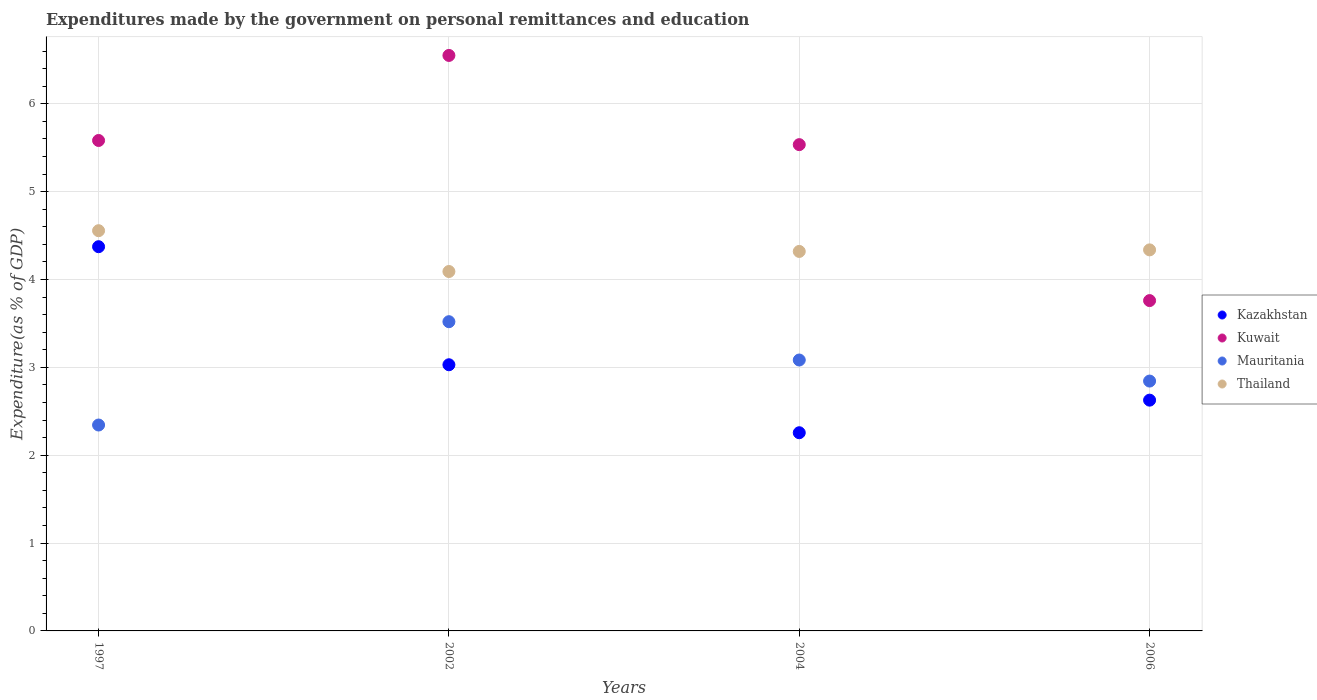Is the number of dotlines equal to the number of legend labels?
Give a very brief answer. Yes. What is the expenditures made by the government on personal remittances and education in Mauritania in 2002?
Offer a terse response. 3.52. Across all years, what is the maximum expenditures made by the government on personal remittances and education in Kuwait?
Your response must be concise. 6.55. Across all years, what is the minimum expenditures made by the government on personal remittances and education in Kazakhstan?
Ensure brevity in your answer.  2.26. In which year was the expenditures made by the government on personal remittances and education in Mauritania minimum?
Your answer should be compact. 1997. What is the total expenditures made by the government on personal remittances and education in Thailand in the graph?
Offer a very short reply. 17.3. What is the difference between the expenditures made by the government on personal remittances and education in Kuwait in 1997 and that in 2002?
Your answer should be compact. -0.97. What is the difference between the expenditures made by the government on personal remittances and education in Kazakhstan in 2006 and the expenditures made by the government on personal remittances and education in Kuwait in 1997?
Your answer should be very brief. -2.96. What is the average expenditures made by the government on personal remittances and education in Thailand per year?
Provide a short and direct response. 4.33. In the year 2002, what is the difference between the expenditures made by the government on personal remittances and education in Kuwait and expenditures made by the government on personal remittances and education in Kazakhstan?
Offer a terse response. 3.52. What is the ratio of the expenditures made by the government on personal remittances and education in Kuwait in 2002 to that in 2006?
Offer a very short reply. 1.74. Is the expenditures made by the government on personal remittances and education in Thailand in 1997 less than that in 2004?
Offer a terse response. No. What is the difference between the highest and the second highest expenditures made by the government on personal remittances and education in Kuwait?
Ensure brevity in your answer.  0.97. What is the difference between the highest and the lowest expenditures made by the government on personal remittances and education in Mauritania?
Your answer should be compact. 1.18. Is the sum of the expenditures made by the government on personal remittances and education in Thailand in 1997 and 2004 greater than the maximum expenditures made by the government on personal remittances and education in Kazakhstan across all years?
Ensure brevity in your answer.  Yes. Is it the case that in every year, the sum of the expenditures made by the government on personal remittances and education in Thailand and expenditures made by the government on personal remittances and education in Kuwait  is greater than the expenditures made by the government on personal remittances and education in Kazakhstan?
Provide a succinct answer. Yes. Does the expenditures made by the government on personal remittances and education in Kazakhstan monotonically increase over the years?
Make the answer very short. No. Is the expenditures made by the government on personal remittances and education in Kazakhstan strictly greater than the expenditures made by the government on personal remittances and education in Mauritania over the years?
Your response must be concise. No. How many dotlines are there?
Provide a succinct answer. 4. How many years are there in the graph?
Give a very brief answer. 4. What is the difference between two consecutive major ticks on the Y-axis?
Provide a succinct answer. 1. Does the graph contain any zero values?
Ensure brevity in your answer.  No. Does the graph contain grids?
Your response must be concise. Yes. How many legend labels are there?
Give a very brief answer. 4. How are the legend labels stacked?
Offer a very short reply. Vertical. What is the title of the graph?
Your answer should be very brief. Expenditures made by the government on personal remittances and education. Does "Ghana" appear as one of the legend labels in the graph?
Your response must be concise. No. What is the label or title of the Y-axis?
Offer a terse response. Expenditure(as % of GDP). What is the Expenditure(as % of GDP) in Kazakhstan in 1997?
Give a very brief answer. 4.37. What is the Expenditure(as % of GDP) in Kuwait in 1997?
Provide a short and direct response. 5.58. What is the Expenditure(as % of GDP) of Mauritania in 1997?
Ensure brevity in your answer.  2.34. What is the Expenditure(as % of GDP) in Thailand in 1997?
Offer a terse response. 4.56. What is the Expenditure(as % of GDP) of Kazakhstan in 2002?
Provide a short and direct response. 3.03. What is the Expenditure(as % of GDP) in Kuwait in 2002?
Provide a succinct answer. 6.55. What is the Expenditure(as % of GDP) of Mauritania in 2002?
Your response must be concise. 3.52. What is the Expenditure(as % of GDP) in Thailand in 2002?
Provide a succinct answer. 4.09. What is the Expenditure(as % of GDP) of Kazakhstan in 2004?
Make the answer very short. 2.26. What is the Expenditure(as % of GDP) in Kuwait in 2004?
Offer a terse response. 5.54. What is the Expenditure(as % of GDP) in Mauritania in 2004?
Your response must be concise. 3.08. What is the Expenditure(as % of GDP) of Thailand in 2004?
Your response must be concise. 4.32. What is the Expenditure(as % of GDP) of Kazakhstan in 2006?
Your answer should be compact. 2.63. What is the Expenditure(as % of GDP) in Kuwait in 2006?
Give a very brief answer. 3.76. What is the Expenditure(as % of GDP) in Mauritania in 2006?
Offer a terse response. 2.84. What is the Expenditure(as % of GDP) in Thailand in 2006?
Provide a succinct answer. 4.34. Across all years, what is the maximum Expenditure(as % of GDP) of Kazakhstan?
Your answer should be compact. 4.37. Across all years, what is the maximum Expenditure(as % of GDP) in Kuwait?
Keep it short and to the point. 6.55. Across all years, what is the maximum Expenditure(as % of GDP) in Mauritania?
Give a very brief answer. 3.52. Across all years, what is the maximum Expenditure(as % of GDP) of Thailand?
Keep it short and to the point. 4.56. Across all years, what is the minimum Expenditure(as % of GDP) of Kazakhstan?
Ensure brevity in your answer.  2.26. Across all years, what is the minimum Expenditure(as % of GDP) of Kuwait?
Make the answer very short. 3.76. Across all years, what is the minimum Expenditure(as % of GDP) in Mauritania?
Your response must be concise. 2.34. Across all years, what is the minimum Expenditure(as % of GDP) of Thailand?
Offer a very short reply. 4.09. What is the total Expenditure(as % of GDP) of Kazakhstan in the graph?
Your answer should be very brief. 12.29. What is the total Expenditure(as % of GDP) in Kuwait in the graph?
Ensure brevity in your answer.  21.43. What is the total Expenditure(as % of GDP) in Mauritania in the graph?
Provide a short and direct response. 11.79. What is the total Expenditure(as % of GDP) in Thailand in the graph?
Your answer should be compact. 17.3. What is the difference between the Expenditure(as % of GDP) in Kazakhstan in 1997 and that in 2002?
Offer a very short reply. 1.34. What is the difference between the Expenditure(as % of GDP) in Kuwait in 1997 and that in 2002?
Make the answer very short. -0.97. What is the difference between the Expenditure(as % of GDP) in Mauritania in 1997 and that in 2002?
Offer a very short reply. -1.18. What is the difference between the Expenditure(as % of GDP) in Thailand in 1997 and that in 2002?
Your response must be concise. 0.46. What is the difference between the Expenditure(as % of GDP) in Kazakhstan in 1997 and that in 2004?
Provide a short and direct response. 2.12. What is the difference between the Expenditure(as % of GDP) of Kuwait in 1997 and that in 2004?
Offer a terse response. 0.05. What is the difference between the Expenditure(as % of GDP) of Mauritania in 1997 and that in 2004?
Give a very brief answer. -0.74. What is the difference between the Expenditure(as % of GDP) of Thailand in 1997 and that in 2004?
Give a very brief answer. 0.24. What is the difference between the Expenditure(as % of GDP) of Kazakhstan in 1997 and that in 2006?
Offer a very short reply. 1.75. What is the difference between the Expenditure(as % of GDP) of Kuwait in 1997 and that in 2006?
Offer a terse response. 1.82. What is the difference between the Expenditure(as % of GDP) of Mauritania in 1997 and that in 2006?
Your answer should be compact. -0.5. What is the difference between the Expenditure(as % of GDP) in Thailand in 1997 and that in 2006?
Offer a terse response. 0.22. What is the difference between the Expenditure(as % of GDP) of Kazakhstan in 2002 and that in 2004?
Provide a succinct answer. 0.77. What is the difference between the Expenditure(as % of GDP) of Kuwait in 2002 and that in 2004?
Make the answer very short. 1.02. What is the difference between the Expenditure(as % of GDP) of Mauritania in 2002 and that in 2004?
Offer a very short reply. 0.44. What is the difference between the Expenditure(as % of GDP) in Thailand in 2002 and that in 2004?
Give a very brief answer. -0.23. What is the difference between the Expenditure(as % of GDP) in Kazakhstan in 2002 and that in 2006?
Provide a short and direct response. 0.4. What is the difference between the Expenditure(as % of GDP) in Kuwait in 2002 and that in 2006?
Your answer should be very brief. 2.79. What is the difference between the Expenditure(as % of GDP) of Mauritania in 2002 and that in 2006?
Keep it short and to the point. 0.68. What is the difference between the Expenditure(as % of GDP) of Thailand in 2002 and that in 2006?
Your answer should be very brief. -0.25. What is the difference between the Expenditure(as % of GDP) in Kazakhstan in 2004 and that in 2006?
Provide a short and direct response. -0.37. What is the difference between the Expenditure(as % of GDP) of Kuwait in 2004 and that in 2006?
Offer a terse response. 1.78. What is the difference between the Expenditure(as % of GDP) of Mauritania in 2004 and that in 2006?
Your answer should be compact. 0.24. What is the difference between the Expenditure(as % of GDP) in Thailand in 2004 and that in 2006?
Your answer should be compact. -0.02. What is the difference between the Expenditure(as % of GDP) in Kazakhstan in 1997 and the Expenditure(as % of GDP) in Kuwait in 2002?
Keep it short and to the point. -2.18. What is the difference between the Expenditure(as % of GDP) in Kazakhstan in 1997 and the Expenditure(as % of GDP) in Mauritania in 2002?
Keep it short and to the point. 0.85. What is the difference between the Expenditure(as % of GDP) in Kazakhstan in 1997 and the Expenditure(as % of GDP) in Thailand in 2002?
Your answer should be compact. 0.28. What is the difference between the Expenditure(as % of GDP) in Kuwait in 1997 and the Expenditure(as % of GDP) in Mauritania in 2002?
Make the answer very short. 2.06. What is the difference between the Expenditure(as % of GDP) in Kuwait in 1997 and the Expenditure(as % of GDP) in Thailand in 2002?
Give a very brief answer. 1.49. What is the difference between the Expenditure(as % of GDP) in Mauritania in 1997 and the Expenditure(as % of GDP) in Thailand in 2002?
Your answer should be very brief. -1.75. What is the difference between the Expenditure(as % of GDP) in Kazakhstan in 1997 and the Expenditure(as % of GDP) in Kuwait in 2004?
Provide a succinct answer. -1.16. What is the difference between the Expenditure(as % of GDP) of Kazakhstan in 1997 and the Expenditure(as % of GDP) of Mauritania in 2004?
Ensure brevity in your answer.  1.29. What is the difference between the Expenditure(as % of GDP) in Kazakhstan in 1997 and the Expenditure(as % of GDP) in Thailand in 2004?
Your answer should be compact. 0.05. What is the difference between the Expenditure(as % of GDP) in Kuwait in 1997 and the Expenditure(as % of GDP) in Mauritania in 2004?
Your answer should be very brief. 2.5. What is the difference between the Expenditure(as % of GDP) of Kuwait in 1997 and the Expenditure(as % of GDP) of Thailand in 2004?
Offer a terse response. 1.26. What is the difference between the Expenditure(as % of GDP) of Mauritania in 1997 and the Expenditure(as % of GDP) of Thailand in 2004?
Offer a very short reply. -1.98. What is the difference between the Expenditure(as % of GDP) of Kazakhstan in 1997 and the Expenditure(as % of GDP) of Kuwait in 2006?
Your answer should be compact. 0.61. What is the difference between the Expenditure(as % of GDP) of Kazakhstan in 1997 and the Expenditure(as % of GDP) of Mauritania in 2006?
Ensure brevity in your answer.  1.53. What is the difference between the Expenditure(as % of GDP) in Kazakhstan in 1997 and the Expenditure(as % of GDP) in Thailand in 2006?
Keep it short and to the point. 0.04. What is the difference between the Expenditure(as % of GDP) of Kuwait in 1997 and the Expenditure(as % of GDP) of Mauritania in 2006?
Keep it short and to the point. 2.74. What is the difference between the Expenditure(as % of GDP) in Kuwait in 1997 and the Expenditure(as % of GDP) in Thailand in 2006?
Your response must be concise. 1.25. What is the difference between the Expenditure(as % of GDP) of Mauritania in 1997 and the Expenditure(as % of GDP) of Thailand in 2006?
Provide a succinct answer. -1.99. What is the difference between the Expenditure(as % of GDP) in Kazakhstan in 2002 and the Expenditure(as % of GDP) in Kuwait in 2004?
Keep it short and to the point. -2.51. What is the difference between the Expenditure(as % of GDP) of Kazakhstan in 2002 and the Expenditure(as % of GDP) of Mauritania in 2004?
Provide a short and direct response. -0.05. What is the difference between the Expenditure(as % of GDP) of Kazakhstan in 2002 and the Expenditure(as % of GDP) of Thailand in 2004?
Give a very brief answer. -1.29. What is the difference between the Expenditure(as % of GDP) in Kuwait in 2002 and the Expenditure(as % of GDP) in Mauritania in 2004?
Your answer should be very brief. 3.47. What is the difference between the Expenditure(as % of GDP) of Kuwait in 2002 and the Expenditure(as % of GDP) of Thailand in 2004?
Your response must be concise. 2.23. What is the difference between the Expenditure(as % of GDP) in Mauritania in 2002 and the Expenditure(as % of GDP) in Thailand in 2004?
Offer a very short reply. -0.8. What is the difference between the Expenditure(as % of GDP) in Kazakhstan in 2002 and the Expenditure(as % of GDP) in Kuwait in 2006?
Offer a terse response. -0.73. What is the difference between the Expenditure(as % of GDP) in Kazakhstan in 2002 and the Expenditure(as % of GDP) in Mauritania in 2006?
Provide a short and direct response. 0.19. What is the difference between the Expenditure(as % of GDP) of Kazakhstan in 2002 and the Expenditure(as % of GDP) of Thailand in 2006?
Your answer should be very brief. -1.31. What is the difference between the Expenditure(as % of GDP) in Kuwait in 2002 and the Expenditure(as % of GDP) in Mauritania in 2006?
Ensure brevity in your answer.  3.71. What is the difference between the Expenditure(as % of GDP) of Kuwait in 2002 and the Expenditure(as % of GDP) of Thailand in 2006?
Keep it short and to the point. 2.21. What is the difference between the Expenditure(as % of GDP) in Mauritania in 2002 and the Expenditure(as % of GDP) in Thailand in 2006?
Offer a very short reply. -0.82. What is the difference between the Expenditure(as % of GDP) in Kazakhstan in 2004 and the Expenditure(as % of GDP) in Kuwait in 2006?
Your response must be concise. -1.5. What is the difference between the Expenditure(as % of GDP) of Kazakhstan in 2004 and the Expenditure(as % of GDP) of Mauritania in 2006?
Your answer should be compact. -0.59. What is the difference between the Expenditure(as % of GDP) in Kazakhstan in 2004 and the Expenditure(as % of GDP) in Thailand in 2006?
Provide a short and direct response. -2.08. What is the difference between the Expenditure(as % of GDP) of Kuwait in 2004 and the Expenditure(as % of GDP) of Mauritania in 2006?
Your answer should be very brief. 2.69. What is the difference between the Expenditure(as % of GDP) in Kuwait in 2004 and the Expenditure(as % of GDP) in Thailand in 2006?
Offer a very short reply. 1.2. What is the difference between the Expenditure(as % of GDP) of Mauritania in 2004 and the Expenditure(as % of GDP) of Thailand in 2006?
Give a very brief answer. -1.25. What is the average Expenditure(as % of GDP) of Kazakhstan per year?
Your answer should be compact. 3.07. What is the average Expenditure(as % of GDP) of Kuwait per year?
Ensure brevity in your answer.  5.36. What is the average Expenditure(as % of GDP) in Mauritania per year?
Offer a terse response. 2.95. What is the average Expenditure(as % of GDP) of Thailand per year?
Provide a short and direct response. 4.33. In the year 1997, what is the difference between the Expenditure(as % of GDP) of Kazakhstan and Expenditure(as % of GDP) of Kuwait?
Offer a terse response. -1.21. In the year 1997, what is the difference between the Expenditure(as % of GDP) in Kazakhstan and Expenditure(as % of GDP) in Mauritania?
Make the answer very short. 2.03. In the year 1997, what is the difference between the Expenditure(as % of GDP) of Kazakhstan and Expenditure(as % of GDP) of Thailand?
Keep it short and to the point. -0.18. In the year 1997, what is the difference between the Expenditure(as % of GDP) of Kuwait and Expenditure(as % of GDP) of Mauritania?
Your answer should be very brief. 3.24. In the year 1997, what is the difference between the Expenditure(as % of GDP) of Kuwait and Expenditure(as % of GDP) of Thailand?
Your answer should be compact. 1.03. In the year 1997, what is the difference between the Expenditure(as % of GDP) of Mauritania and Expenditure(as % of GDP) of Thailand?
Give a very brief answer. -2.21. In the year 2002, what is the difference between the Expenditure(as % of GDP) in Kazakhstan and Expenditure(as % of GDP) in Kuwait?
Offer a very short reply. -3.52. In the year 2002, what is the difference between the Expenditure(as % of GDP) of Kazakhstan and Expenditure(as % of GDP) of Mauritania?
Provide a succinct answer. -0.49. In the year 2002, what is the difference between the Expenditure(as % of GDP) in Kazakhstan and Expenditure(as % of GDP) in Thailand?
Ensure brevity in your answer.  -1.06. In the year 2002, what is the difference between the Expenditure(as % of GDP) in Kuwait and Expenditure(as % of GDP) in Mauritania?
Your answer should be very brief. 3.03. In the year 2002, what is the difference between the Expenditure(as % of GDP) of Kuwait and Expenditure(as % of GDP) of Thailand?
Your answer should be very brief. 2.46. In the year 2002, what is the difference between the Expenditure(as % of GDP) in Mauritania and Expenditure(as % of GDP) in Thailand?
Offer a terse response. -0.57. In the year 2004, what is the difference between the Expenditure(as % of GDP) of Kazakhstan and Expenditure(as % of GDP) of Kuwait?
Your response must be concise. -3.28. In the year 2004, what is the difference between the Expenditure(as % of GDP) of Kazakhstan and Expenditure(as % of GDP) of Mauritania?
Keep it short and to the point. -0.83. In the year 2004, what is the difference between the Expenditure(as % of GDP) in Kazakhstan and Expenditure(as % of GDP) in Thailand?
Make the answer very short. -2.06. In the year 2004, what is the difference between the Expenditure(as % of GDP) of Kuwait and Expenditure(as % of GDP) of Mauritania?
Offer a very short reply. 2.45. In the year 2004, what is the difference between the Expenditure(as % of GDP) in Kuwait and Expenditure(as % of GDP) in Thailand?
Ensure brevity in your answer.  1.22. In the year 2004, what is the difference between the Expenditure(as % of GDP) of Mauritania and Expenditure(as % of GDP) of Thailand?
Ensure brevity in your answer.  -1.24. In the year 2006, what is the difference between the Expenditure(as % of GDP) in Kazakhstan and Expenditure(as % of GDP) in Kuwait?
Your answer should be compact. -1.13. In the year 2006, what is the difference between the Expenditure(as % of GDP) of Kazakhstan and Expenditure(as % of GDP) of Mauritania?
Make the answer very short. -0.22. In the year 2006, what is the difference between the Expenditure(as % of GDP) of Kazakhstan and Expenditure(as % of GDP) of Thailand?
Provide a short and direct response. -1.71. In the year 2006, what is the difference between the Expenditure(as % of GDP) in Kuwait and Expenditure(as % of GDP) in Mauritania?
Your answer should be very brief. 0.92. In the year 2006, what is the difference between the Expenditure(as % of GDP) in Kuwait and Expenditure(as % of GDP) in Thailand?
Offer a terse response. -0.58. In the year 2006, what is the difference between the Expenditure(as % of GDP) of Mauritania and Expenditure(as % of GDP) of Thailand?
Your answer should be very brief. -1.49. What is the ratio of the Expenditure(as % of GDP) of Kazakhstan in 1997 to that in 2002?
Give a very brief answer. 1.44. What is the ratio of the Expenditure(as % of GDP) of Kuwait in 1997 to that in 2002?
Ensure brevity in your answer.  0.85. What is the ratio of the Expenditure(as % of GDP) in Mauritania in 1997 to that in 2002?
Make the answer very short. 0.67. What is the ratio of the Expenditure(as % of GDP) of Thailand in 1997 to that in 2002?
Your answer should be very brief. 1.11. What is the ratio of the Expenditure(as % of GDP) of Kazakhstan in 1997 to that in 2004?
Your answer should be very brief. 1.94. What is the ratio of the Expenditure(as % of GDP) of Kuwait in 1997 to that in 2004?
Make the answer very short. 1.01. What is the ratio of the Expenditure(as % of GDP) of Mauritania in 1997 to that in 2004?
Keep it short and to the point. 0.76. What is the ratio of the Expenditure(as % of GDP) in Thailand in 1997 to that in 2004?
Offer a terse response. 1.05. What is the ratio of the Expenditure(as % of GDP) in Kazakhstan in 1997 to that in 2006?
Your answer should be compact. 1.66. What is the ratio of the Expenditure(as % of GDP) in Kuwait in 1997 to that in 2006?
Ensure brevity in your answer.  1.48. What is the ratio of the Expenditure(as % of GDP) of Mauritania in 1997 to that in 2006?
Your response must be concise. 0.82. What is the ratio of the Expenditure(as % of GDP) in Thailand in 1997 to that in 2006?
Ensure brevity in your answer.  1.05. What is the ratio of the Expenditure(as % of GDP) in Kazakhstan in 2002 to that in 2004?
Give a very brief answer. 1.34. What is the ratio of the Expenditure(as % of GDP) in Kuwait in 2002 to that in 2004?
Offer a very short reply. 1.18. What is the ratio of the Expenditure(as % of GDP) in Mauritania in 2002 to that in 2004?
Your answer should be very brief. 1.14. What is the ratio of the Expenditure(as % of GDP) of Thailand in 2002 to that in 2004?
Your answer should be very brief. 0.95. What is the ratio of the Expenditure(as % of GDP) of Kazakhstan in 2002 to that in 2006?
Make the answer very short. 1.15. What is the ratio of the Expenditure(as % of GDP) in Kuwait in 2002 to that in 2006?
Offer a very short reply. 1.74. What is the ratio of the Expenditure(as % of GDP) in Mauritania in 2002 to that in 2006?
Make the answer very short. 1.24. What is the ratio of the Expenditure(as % of GDP) of Thailand in 2002 to that in 2006?
Provide a short and direct response. 0.94. What is the ratio of the Expenditure(as % of GDP) of Kazakhstan in 2004 to that in 2006?
Offer a terse response. 0.86. What is the ratio of the Expenditure(as % of GDP) of Kuwait in 2004 to that in 2006?
Provide a short and direct response. 1.47. What is the ratio of the Expenditure(as % of GDP) in Mauritania in 2004 to that in 2006?
Your answer should be very brief. 1.08. What is the difference between the highest and the second highest Expenditure(as % of GDP) in Kazakhstan?
Make the answer very short. 1.34. What is the difference between the highest and the second highest Expenditure(as % of GDP) in Kuwait?
Provide a succinct answer. 0.97. What is the difference between the highest and the second highest Expenditure(as % of GDP) of Mauritania?
Your response must be concise. 0.44. What is the difference between the highest and the second highest Expenditure(as % of GDP) of Thailand?
Ensure brevity in your answer.  0.22. What is the difference between the highest and the lowest Expenditure(as % of GDP) in Kazakhstan?
Your response must be concise. 2.12. What is the difference between the highest and the lowest Expenditure(as % of GDP) of Kuwait?
Your answer should be very brief. 2.79. What is the difference between the highest and the lowest Expenditure(as % of GDP) in Mauritania?
Make the answer very short. 1.18. What is the difference between the highest and the lowest Expenditure(as % of GDP) in Thailand?
Provide a short and direct response. 0.46. 